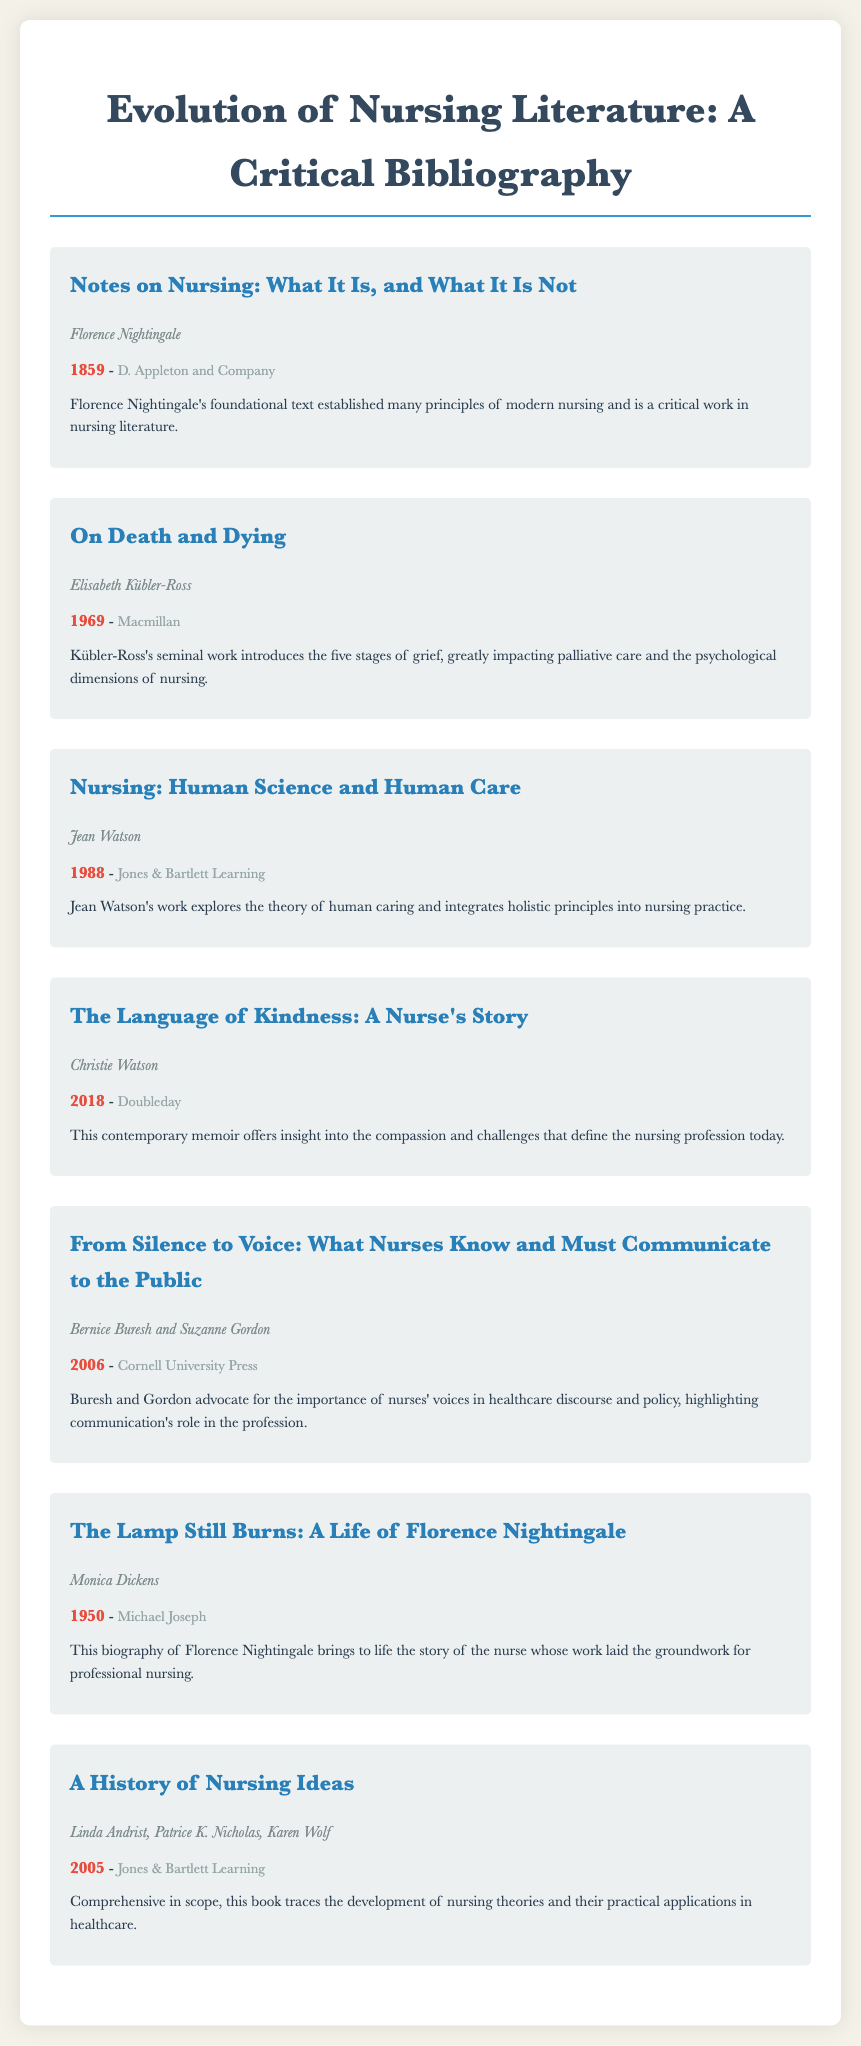what is the title of the first book listed? The title of the first book listed is "Notes on Nursing: What It Is, and What It Is Not."
Answer: "Notes on Nursing: What It Is, and What It Is Not" who is the author of "On Death and Dying"? The author of "On Death and Dying" is Elisabeth Kübler-Ross.
Answer: Elisabeth Kübler-Ross what year was "The Lamp Still Burns: A Life of Florence Nightingale" published? "The Lamp Still Burns: A Life of Florence Nightingale" was published in 1950.
Answer: 1950 which publisher released "Nursing: Human Science and Human Care"? The publisher of "Nursing: Human Science and Human Care" is Jones & Bartlett Learning.
Answer: Jones & Bartlett Learning how many books are listed in total? The document lists a total of seven books.
Answer: seven what key theme is addressed in "From Silence to Voice"? "From Silence to Voice" addresses the importance of communication in nursing.
Answer: communication which author is known for exploring the theory of human caring? Jean Watson is known for exploring the theory of human caring.
Answer: Jean Watson what type of literature does "The Language of Kindness: A Nurse's Story" represent? "The Language of Kindness: A Nurse's Story" represents contemporary memoir.
Answer: contemporary memoir 